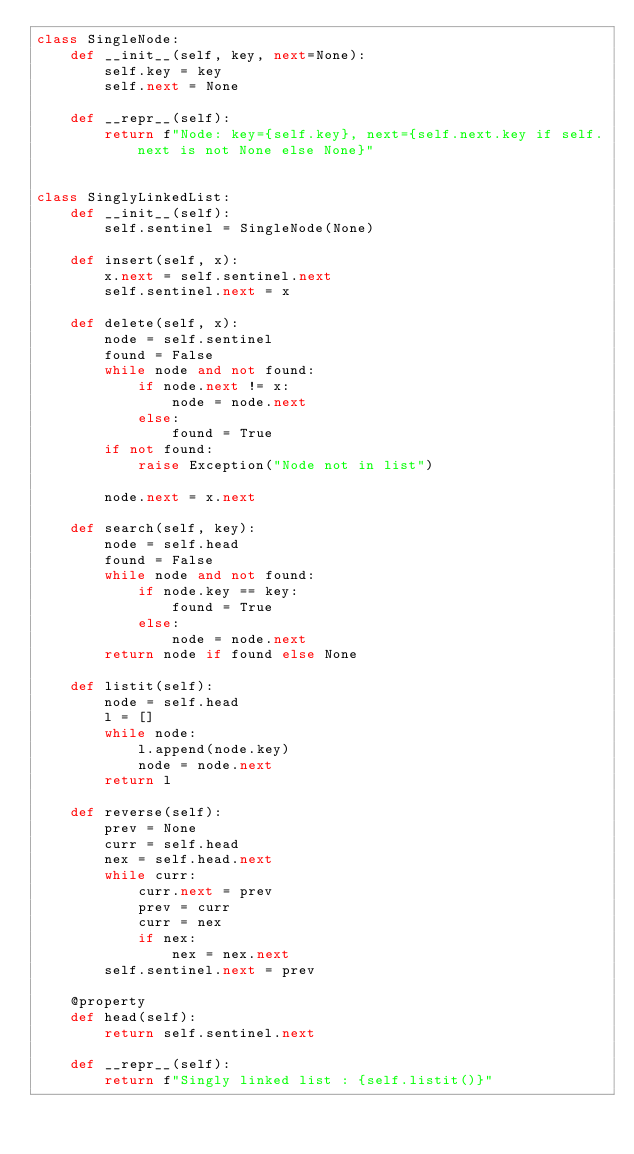Convert code to text. <code><loc_0><loc_0><loc_500><loc_500><_Python_>class SingleNode:
    def __init__(self, key, next=None):
        self.key = key
        self.next = None

    def __repr__(self):
        return f"Node: key={self.key}, next={self.next.key if self.next is not None else None}"


class SinglyLinkedList:
    def __init__(self):
        self.sentinel = SingleNode(None)

    def insert(self, x):
        x.next = self.sentinel.next
        self.sentinel.next = x

    def delete(self, x):
        node = self.sentinel
        found = False
        while node and not found:
            if node.next != x:
                node = node.next
            else:
                found = True
        if not found:
            raise Exception("Node not in list")

        node.next = x.next

    def search(self, key):
        node = self.head
        found = False
        while node and not found:
            if node.key == key:
                found = True
            else:
                node = node.next
        return node if found else None

    def listit(self):
        node = self.head
        l = []
        while node:
            l.append(node.key)
            node = node.next
        return l

    def reverse(self):
        prev = None
        curr = self.head
        nex = self.head.next
        while curr:
            curr.next = prev
            prev = curr
            curr = nex
            if nex:
                nex = nex.next
        self.sentinel.next = prev

    @property
    def head(self):
        return self.sentinel.next

    def __repr__(self):
        return f"Singly linked list : {self.listit()}"

</code> 